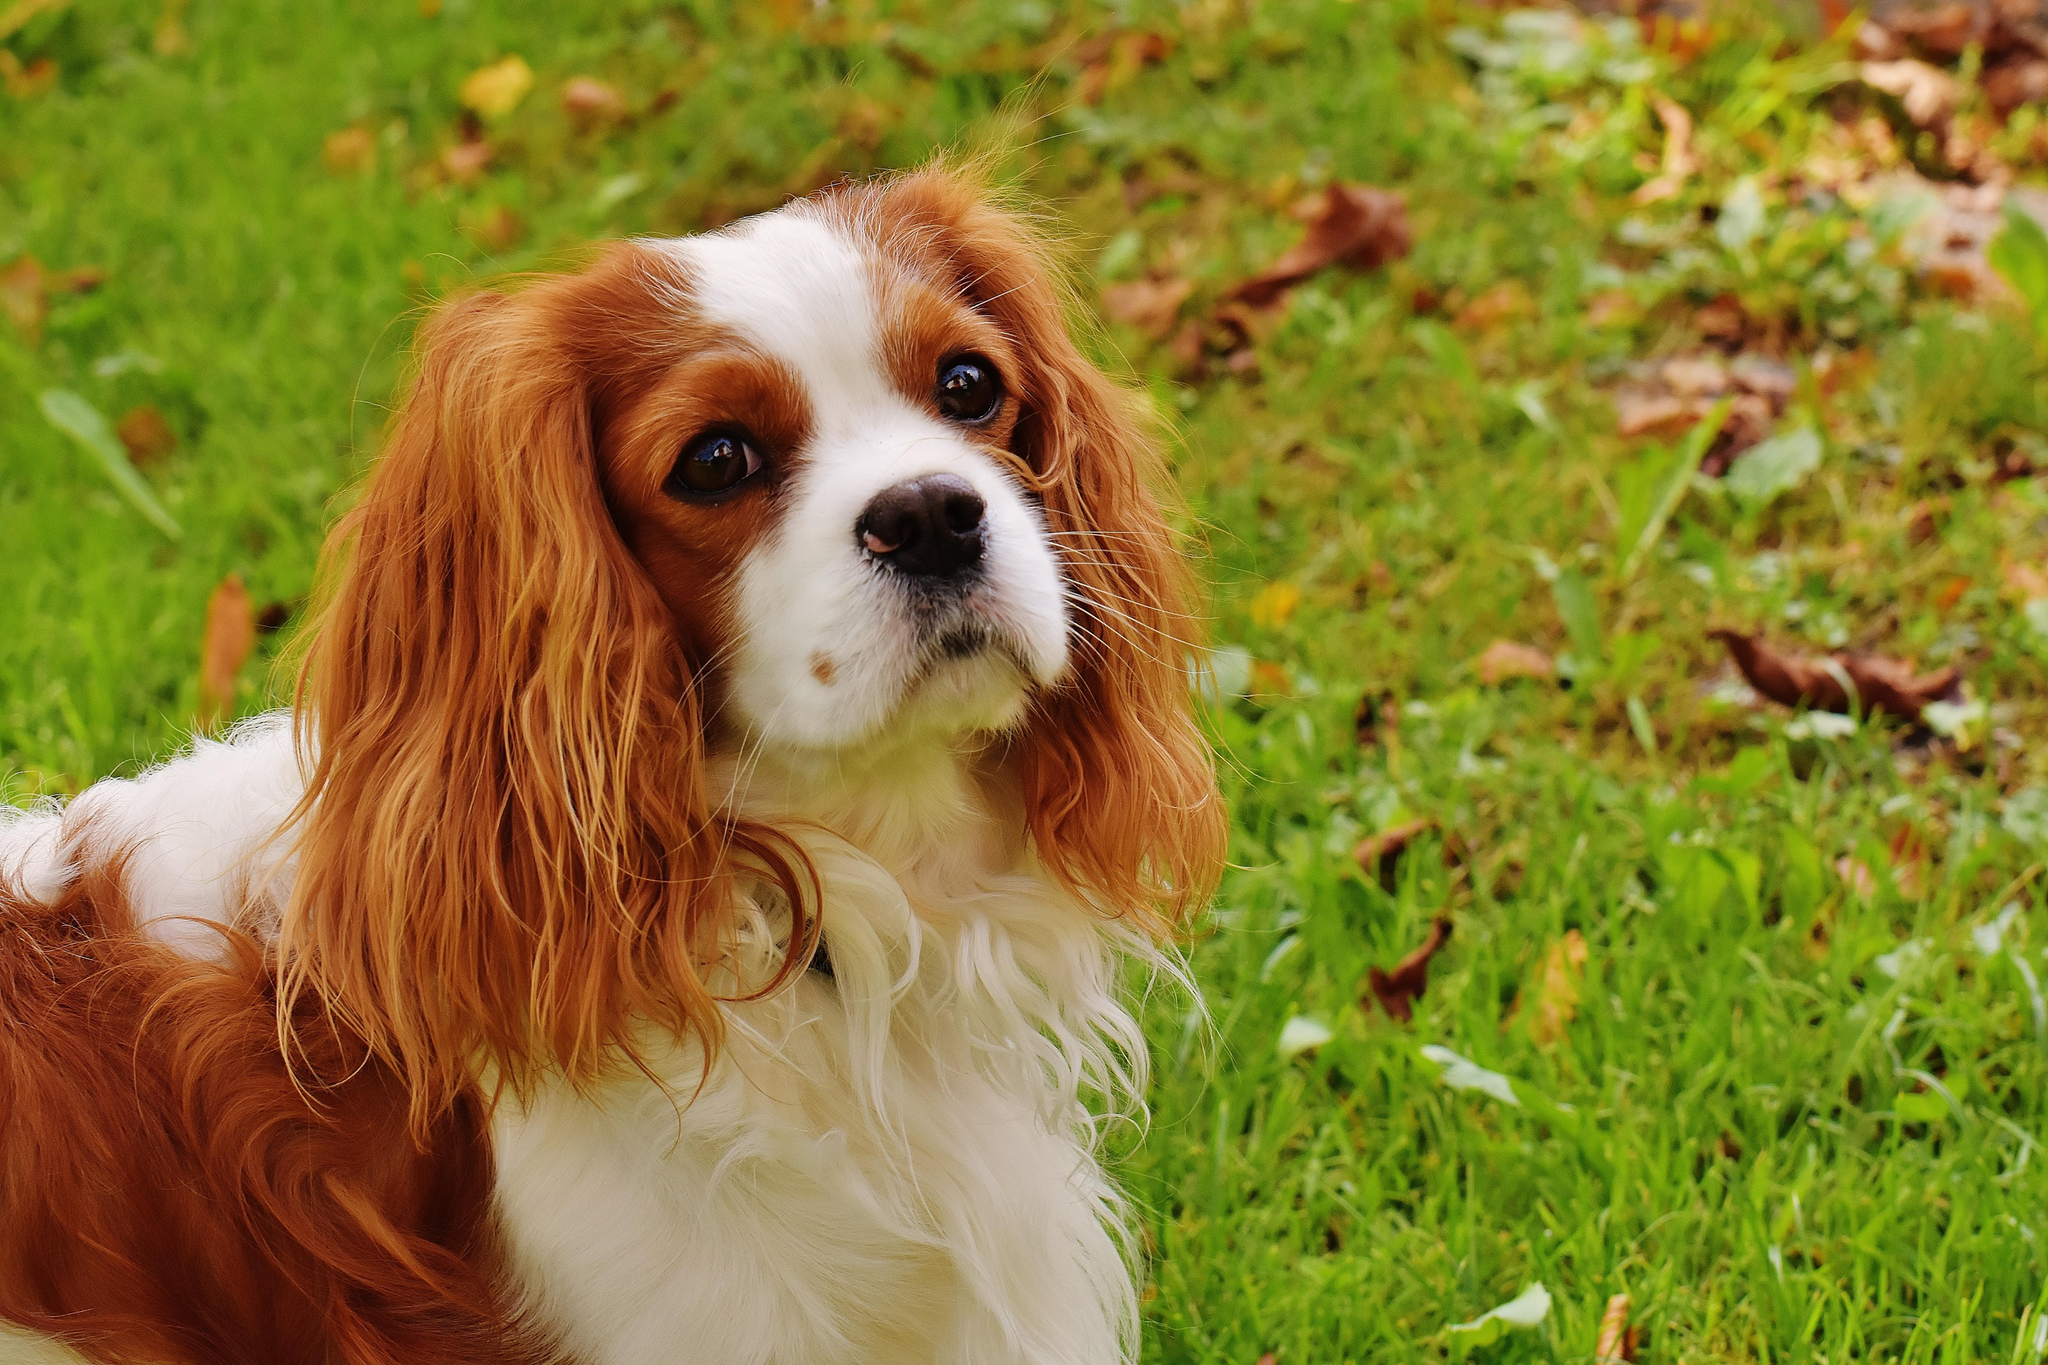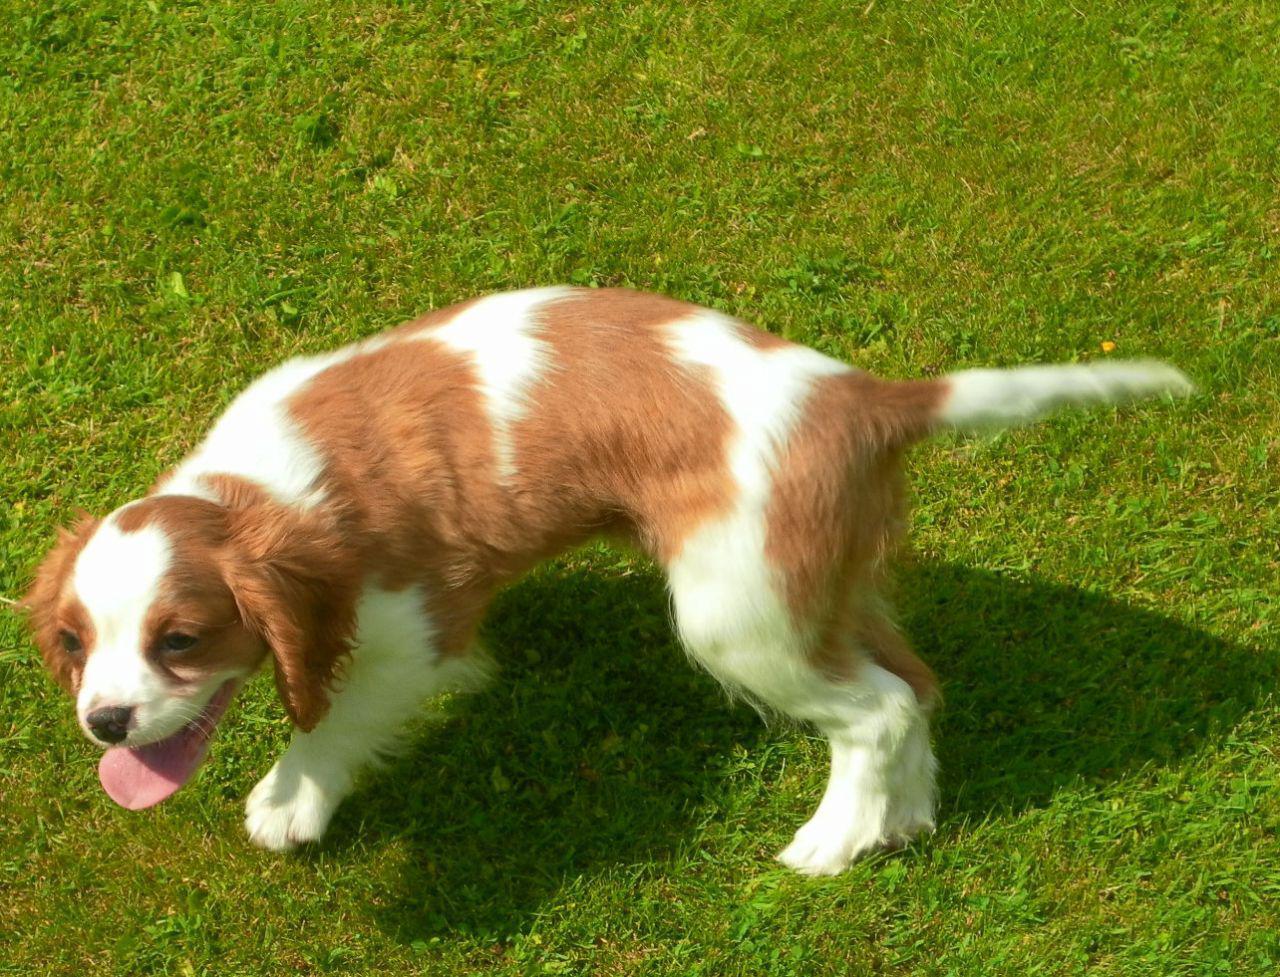The first image is the image on the left, the second image is the image on the right. Analyze the images presented: Is the assertion "Dogs are laying down inside a home" valid? Answer yes or no. No. The first image is the image on the left, the second image is the image on the right. Analyze the images presented: Is the assertion "Each image shows one brown and white dog on green grass." valid? Answer yes or no. Yes. 